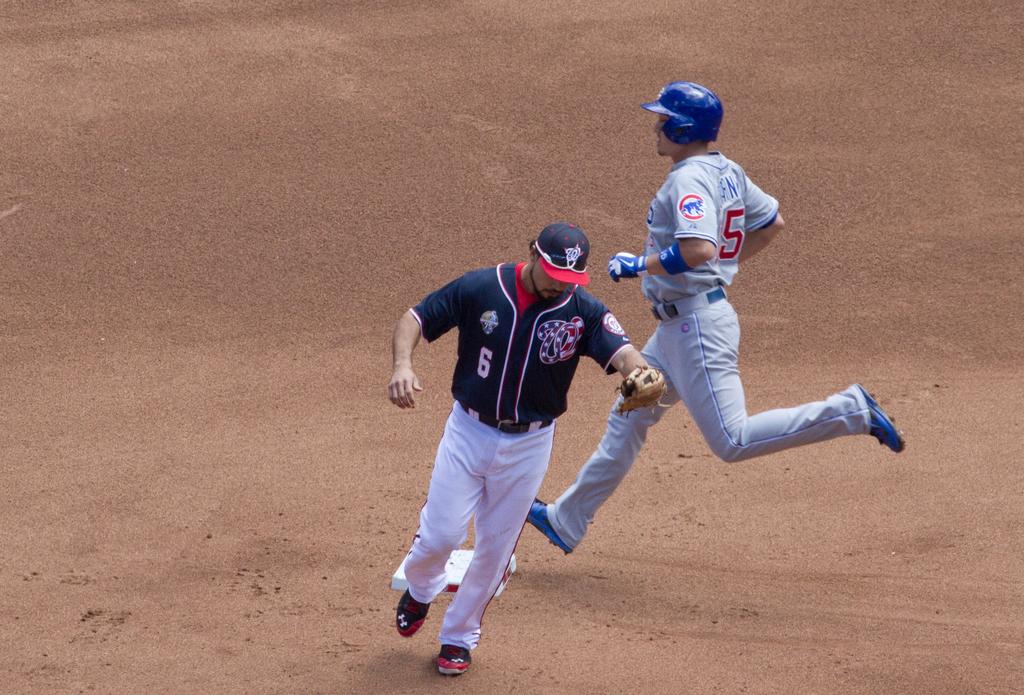What jersey number is seen on the one in blue?
Make the answer very short. 6. What jersey number is on the grey one?
Offer a very short reply. 5. 